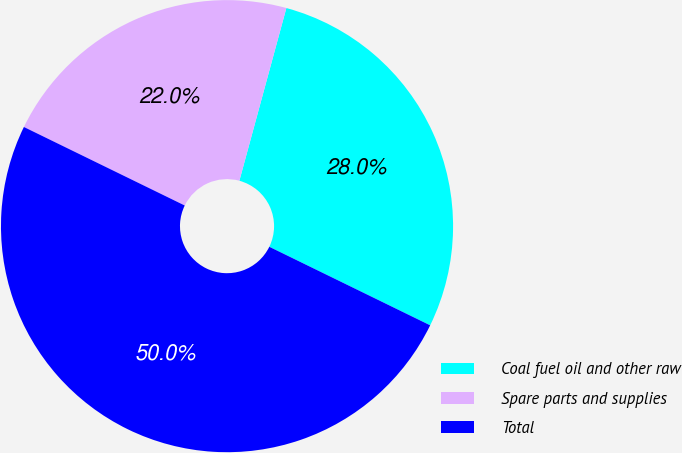Convert chart to OTSL. <chart><loc_0><loc_0><loc_500><loc_500><pie_chart><fcel>Coal fuel oil and other raw<fcel>Spare parts and supplies<fcel>Total<nl><fcel>28.0%<fcel>22.0%<fcel>50.0%<nl></chart> 